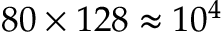Convert formula to latex. <formula><loc_0><loc_0><loc_500><loc_500>8 0 \times 1 2 8 \approx 1 0 ^ { 4 }</formula> 